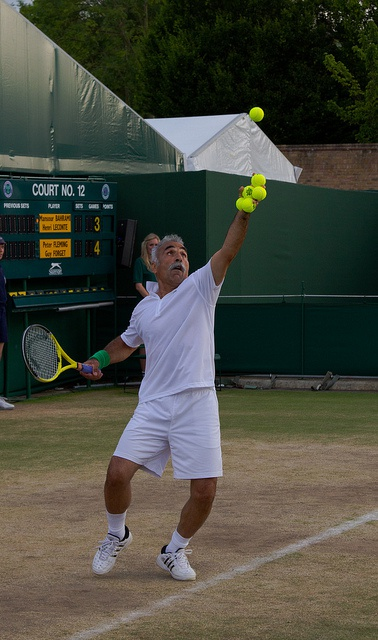Describe the objects in this image and their specific colors. I can see people in darkgray, gray, and maroon tones, tennis racket in darkgray, purple, black, and olive tones, people in darkgray, black, maroon, and gray tones, sports ball in darkgray, olive, khaki, and yellow tones, and sports ball in darkgray, olive, yellow, and khaki tones in this image. 